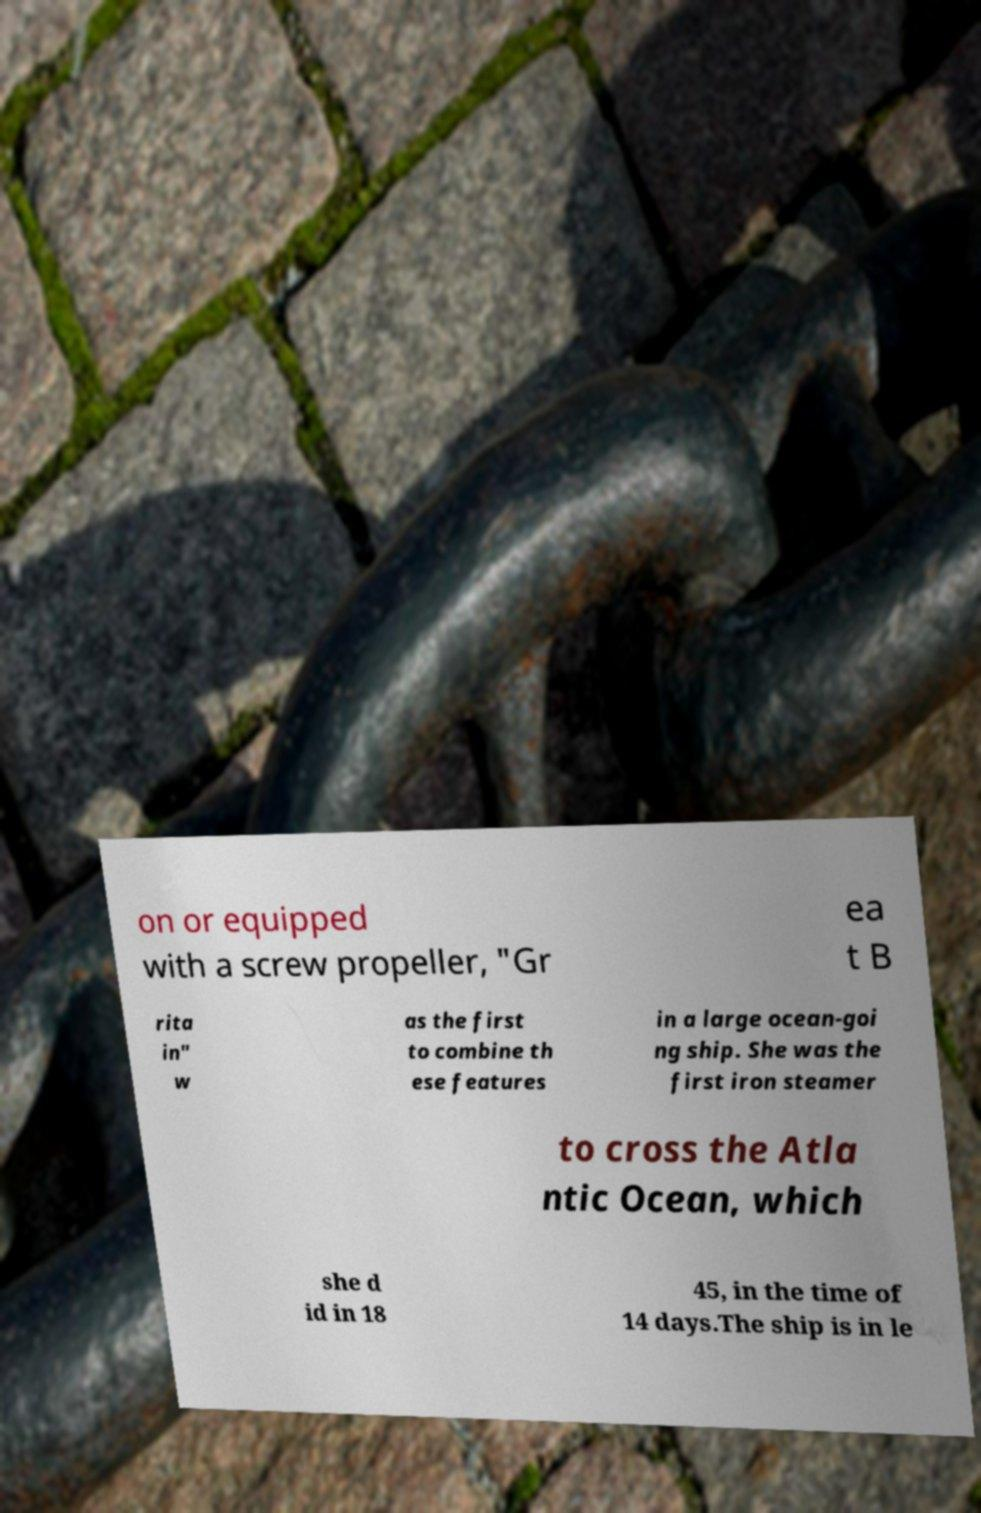I need the written content from this picture converted into text. Can you do that? on or equipped with a screw propeller, "Gr ea t B rita in" w as the first to combine th ese features in a large ocean-goi ng ship. She was the first iron steamer to cross the Atla ntic Ocean, which she d id in 18 45, in the time of 14 days.The ship is in le 